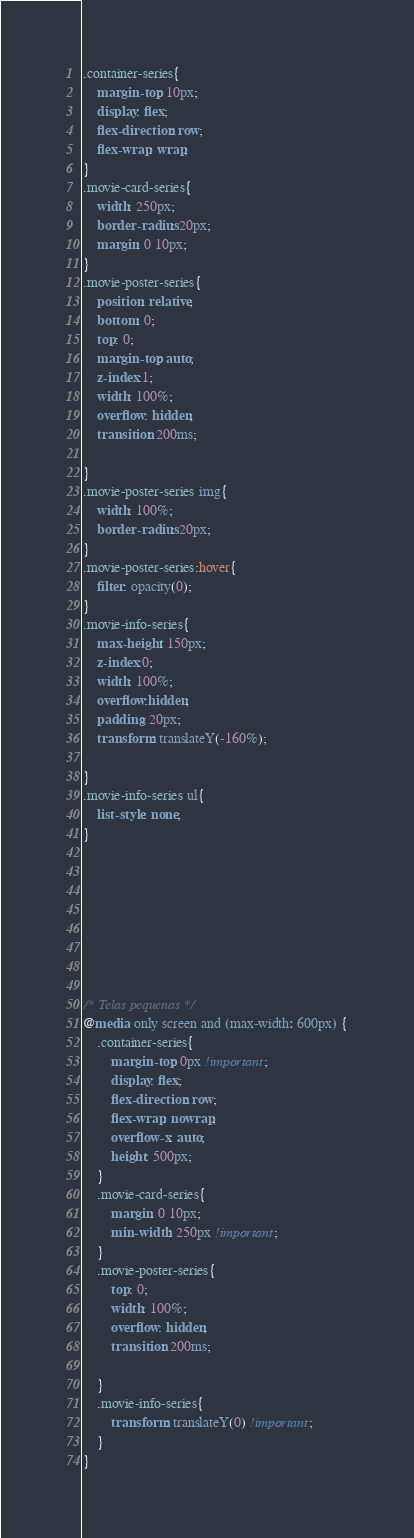<code> <loc_0><loc_0><loc_500><loc_500><_CSS_>

.container-series{
    margin-top: 10px;
    display: flex;
    flex-direction: row;
    flex-wrap: wrap;
}
.movie-card-series{
    width: 250px;
    border-radius: 20px;
    margin: 0 10px;
}
.movie-poster-series{
    position: relative;
    bottom: 0;
    top: 0;
    margin-top: auto;
    z-index:1;
    width: 100%;
    overflow: hidden;
    transition: 200ms;
   
}
.movie-poster-series img{
    width: 100%;
    border-radius: 20px;
}
.movie-poster-series:hover{
    filter: opacity(0);
}
.movie-info-series{
    max-height: 150px;
    z-index:0;
    width: 100%;
    overflow:hidden;
    padding: 20px;
    transform: translateY(-160%);
    
}
.movie-info-series ul{
    list-style: none;
}








/* Telas pequenas */
@media only screen and (max-width: 600px) {
    .container-series{
        margin-top: 0px !important;
        display: flex;
        flex-direction: row;
        flex-wrap: nowrap;
        overflow-x: auto;
        height: 500px;
    }
    .movie-card-series{
        margin: 0 10px;
        min-width: 250px !important;
    }
    .movie-poster-series{
        top: 0;
        width: 100%;
        overflow: hidden;
        transition: 200ms;
       
    }
    .movie-info-series{
        transform: translateY(0) !important;
    }
}



</code> 